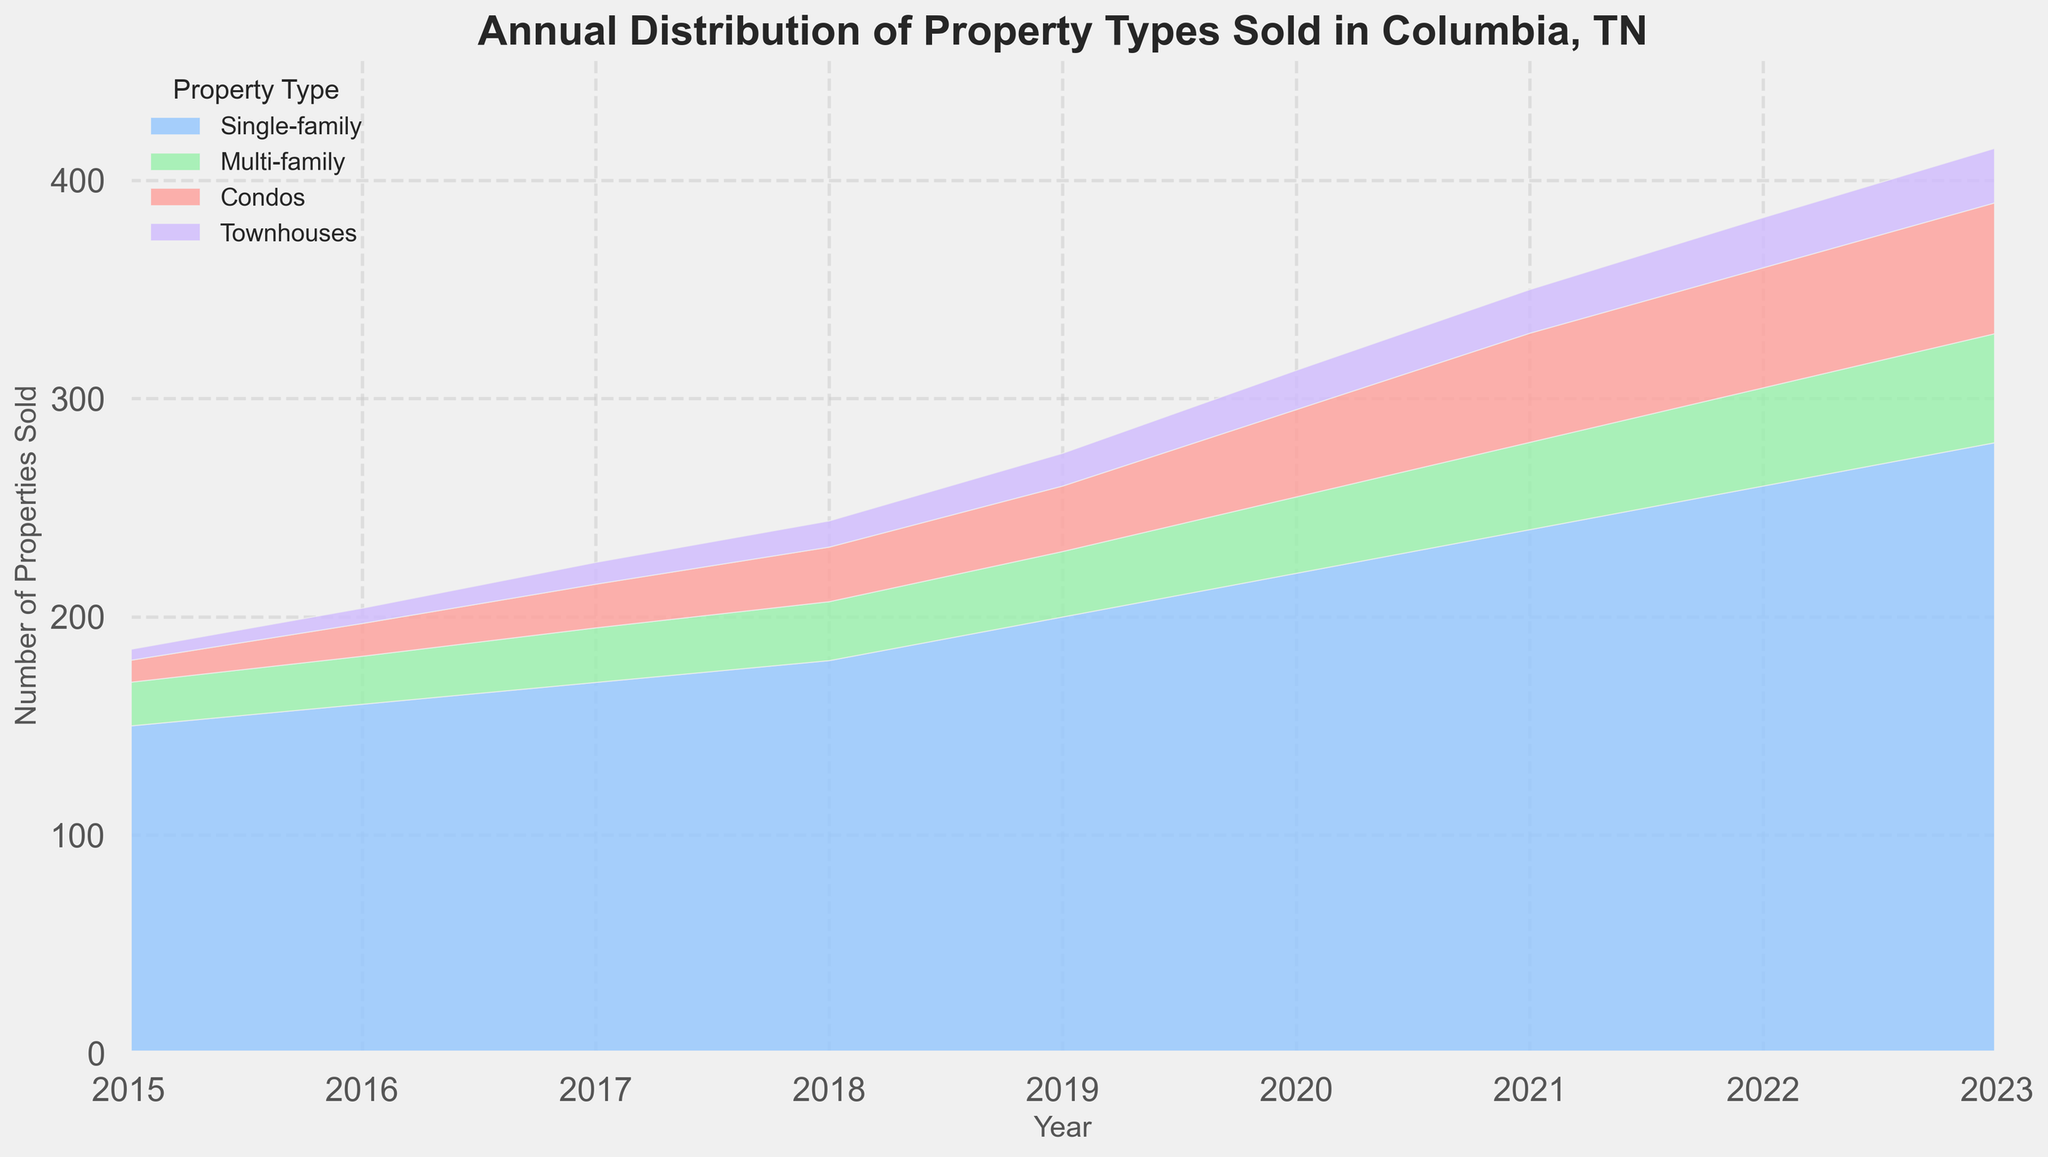what is the total number of properties sold in 2020? To find the total number of properties sold in 2020, sum the values for single-family, multi-family, condos, and townhouses: 220 + 35 + 40 + 18 = 313.
Answer: 313 Which property type saw the largest growth between 2015 and 2023? Compare the values for each property type between 2015 and 2023: Single-family (280-150=130), Multi-family (50-20=30), Condos (60-10=50), and Townhouses (25-5=20). Single-family saw the largest growth (130).
Answer: Single-family What year did multi-family homes surpass 30 properties sold? Check the values for multi-family homes in each year: In 2018 the value is 27, and in 2019 it is 30. Therefore, multi-family homes surpass 30 properties in 2019.
Answer: 2019 How many more townhouses were sold in 2023 compared to 2015? Subtract the number of townhouses sold in 2015 from the number sold in 2023: 25 - 5 = 20.
Answer: 20 Which year had the highest total number of properties sold? Add the number of each property type sold for each year and compare. 2023 has the highest total with 280 + 50 + 60 + 25 = 415.
Answer: 2023 What is the average number of condos sold per year from 2015 to 2023? Sum the number of condos sold from 2015 to 2023 and divide by the number of years: (10 + 15 + 20 + 25 + 30 + 40 + 50 + 55 + 60) / 9 = 305 / 9 ≈ 33.89.
Answer: 33.89 In which year did townhouses reach almost the same number as condos sold? Compare the values of townhouses and condos for each year; in 2023, townhouses sold (25) is closest to condos sold (60), but it's still far off, checking earlier years 2018 and 2021 show similar. confirming 2015-2021
Answer: Check the figure for this comparison, a dynamic view for an attentive agent How many more Single-family homes were sold in 2023 compared to 2015? Subtract 2015 from the 2023 single-family home sales: 280 - 150 = 130
Answer: 130 What was the second highest number of total properties sold in any year? Calculate the totals for each year and identify the second highest: 2022 with 260 + 45 + 55 + 23 = 383 follows the highest in 2023 with 415
Answer: 2022 